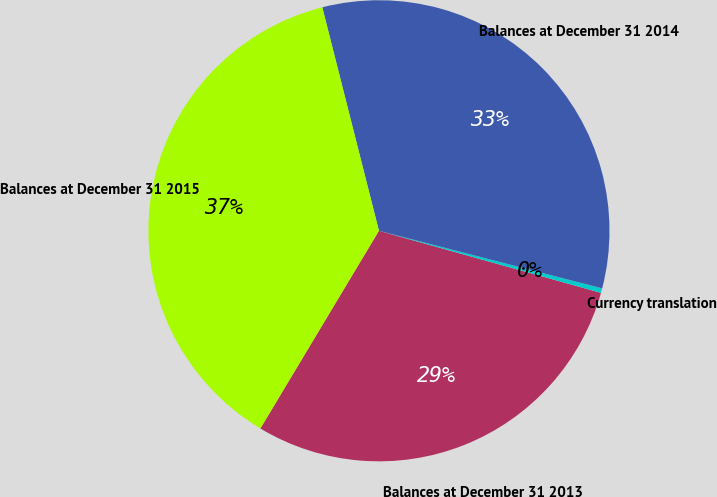Convert chart to OTSL. <chart><loc_0><loc_0><loc_500><loc_500><pie_chart><fcel>Balances at December 31 2013<fcel>Currency translation<fcel>Balances at December 31 2014<fcel>Balances at December 31 2015<nl><fcel>29.26%<fcel>0.32%<fcel>32.97%<fcel>37.45%<nl></chart> 